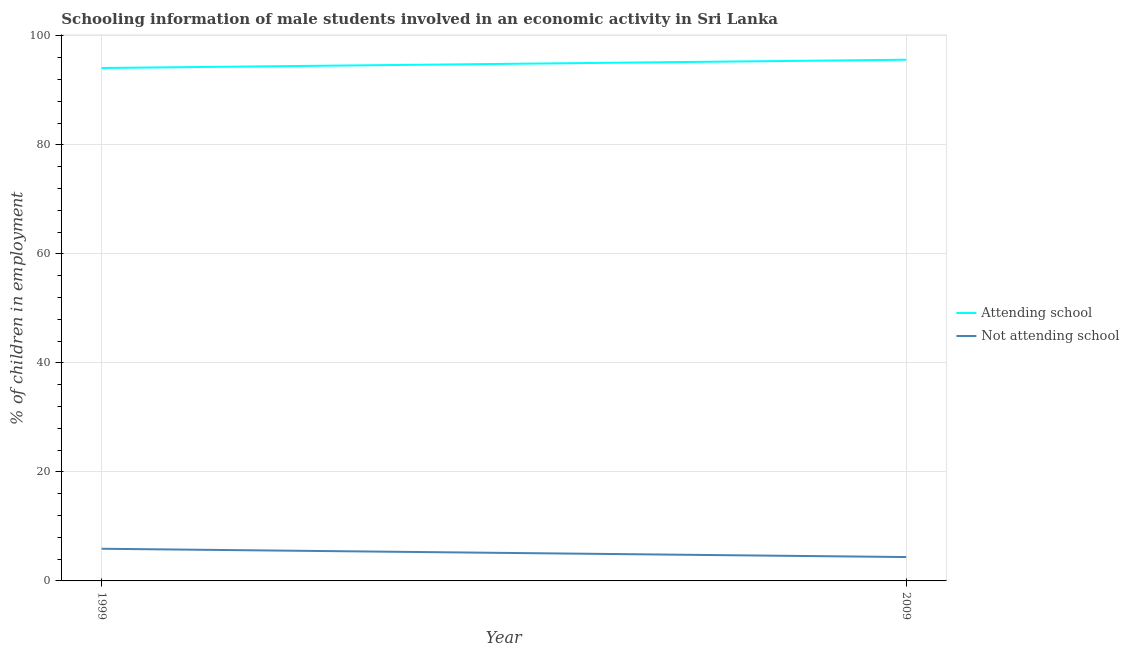Does the line corresponding to percentage of employed males who are attending school intersect with the line corresponding to percentage of employed males who are not attending school?
Your answer should be very brief. No. Is the number of lines equal to the number of legend labels?
Your answer should be very brief. Yes. What is the percentage of employed males who are attending school in 2009?
Offer a terse response. 95.62. Across all years, what is the minimum percentage of employed males who are attending school?
Offer a terse response. 94.1. In which year was the percentage of employed males who are not attending school minimum?
Provide a short and direct response. 2009. What is the total percentage of employed males who are not attending school in the graph?
Keep it short and to the point. 10.28. What is the difference between the percentage of employed males who are attending school in 1999 and that in 2009?
Offer a terse response. -1.52. What is the difference between the percentage of employed males who are not attending school in 2009 and the percentage of employed males who are attending school in 1999?
Your answer should be very brief. -89.72. What is the average percentage of employed males who are not attending school per year?
Ensure brevity in your answer.  5.14. In the year 1999, what is the difference between the percentage of employed males who are not attending school and percentage of employed males who are attending school?
Offer a terse response. -88.2. In how many years, is the percentage of employed males who are attending school greater than 32 %?
Your response must be concise. 2. What is the ratio of the percentage of employed males who are not attending school in 1999 to that in 2009?
Offer a very short reply. 1.35. Is the percentage of employed males who are attending school in 1999 less than that in 2009?
Your answer should be very brief. Yes. Is the percentage of employed males who are not attending school strictly greater than the percentage of employed males who are attending school over the years?
Make the answer very short. No. Is the percentage of employed males who are not attending school strictly less than the percentage of employed males who are attending school over the years?
Give a very brief answer. Yes. How many lines are there?
Provide a succinct answer. 2. What is the difference between two consecutive major ticks on the Y-axis?
Provide a short and direct response. 20. Where does the legend appear in the graph?
Your response must be concise. Center right. What is the title of the graph?
Your answer should be very brief. Schooling information of male students involved in an economic activity in Sri Lanka. Does "Males" appear as one of the legend labels in the graph?
Offer a terse response. No. What is the label or title of the Y-axis?
Your response must be concise. % of children in employment. What is the % of children in employment of Attending school in 1999?
Your answer should be very brief. 94.1. What is the % of children in employment in Not attending school in 1999?
Your response must be concise. 5.9. What is the % of children in employment of Attending school in 2009?
Ensure brevity in your answer.  95.62. What is the % of children in employment of Not attending school in 2009?
Your answer should be very brief. 4.38. Across all years, what is the maximum % of children in employment of Attending school?
Provide a short and direct response. 95.62. Across all years, what is the maximum % of children in employment of Not attending school?
Your answer should be very brief. 5.9. Across all years, what is the minimum % of children in employment in Attending school?
Ensure brevity in your answer.  94.1. Across all years, what is the minimum % of children in employment in Not attending school?
Keep it short and to the point. 4.38. What is the total % of children in employment of Attending school in the graph?
Provide a short and direct response. 189.72. What is the total % of children in employment in Not attending school in the graph?
Keep it short and to the point. 10.28. What is the difference between the % of children in employment in Attending school in 1999 and that in 2009?
Offer a terse response. -1.52. What is the difference between the % of children in employment of Not attending school in 1999 and that in 2009?
Make the answer very short. 1.52. What is the difference between the % of children in employment in Attending school in 1999 and the % of children in employment in Not attending school in 2009?
Make the answer very short. 89.72. What is the average % of children in employment of Attending school per year?
Your response must be concise. 94.86. What is the average % of children in employment in Not attending school per year?
Provide a succinct answer. 5.14. In the year 1999, what is the difference between the % of children in employment of Attending school and % of children in employment of Not attending school?
Provide a short and direct response. 88.2. In the year 2009, what is the difference between the % of children in employment in Attending school and % of children in employment in Not attending school?
Offer a terse response. 91.24. What is the ratio of the % of children in employment of Attending school in 1999 to that in 2009?
Offer a very short reply. 0.98. What is the ratio of the % of children in employment in Not attending school in 1999 to that in 2009?
Ensure brevity in your answer.  1.35. What is the difference between the highest and the second highest % of children in employment in Attending school?
Your response must be concise. 1.52. What is the difference between the highest and the second highest % of children in employment in Not attending school?
Your answer should be compact. 1.52. What is the difference between the highest and the lowest % of children in employment in Attending school?
Your response must be concise. 1.52. What is the difference between the highest and the lowest % of children in employment of Not attending school?
Give a very brief answer. 1.52. 